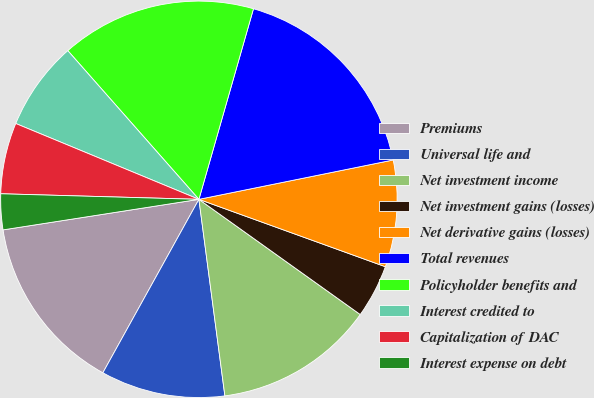Convert chart to OTSL. <chart><loc_0><loc_0><loc_500><loc_500><pie_chart><fcel>Premiums<fcel>Universal life and<fcel>Net investment income<fcel>Net investment gains (losses)<fcel>Net derivative gains (losses)<fcel>Total revenues<fcel>Policyholder benefits and<fcel>Interest credited to<fcel>Capitalization of DAC<fcel>Interest expense on debt<nl><fcel>14.49%<fcel>10.14%<fcel>13.04%<fcel>4.35%<fcel>8.7%<fcel>17.38%<fcel>15.94%<fcel>7.25%<fcel>5.8%<fcel>2.91%<nl></chart> 